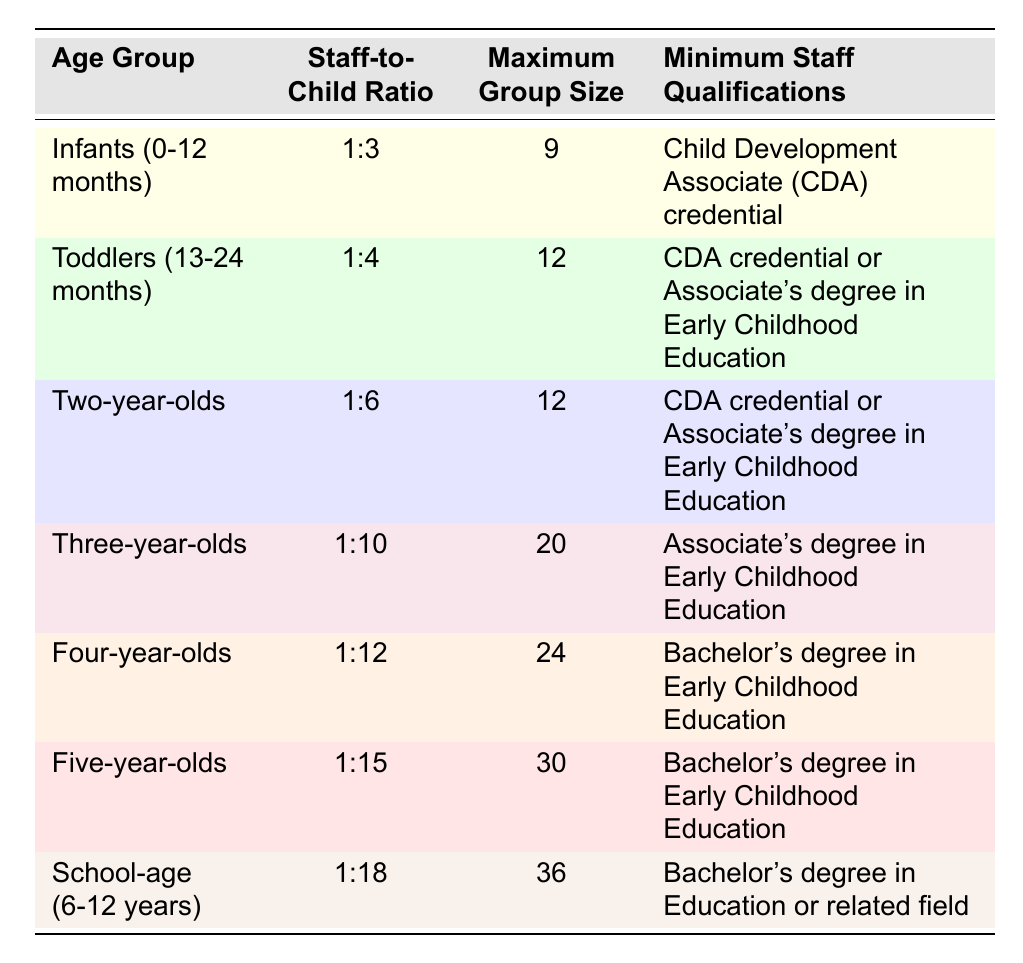What is the staff-to-child ratio for infants? The table states that the staff-to-child ratio for infants (0-12 months) is 1:3.
Answer: 1:3 What maximum group size is allowed for toddlers? According to the table, the maximum group size for toddlers (13-24 months) is 12.
Answer: 12 Do two-year-olds require the same minimum staff qualifications as toddlers? The minimum staff qualifications for both two-year-olds and toddlers are CDA credential or Associate's degree in Early Childhood Education, so the answer is yes.
Answer: Yes What is the maximum group size for four-year-olds and what is the corresponding staff-to-child ratio? The table indicates that the maximum group size for four-year-olds is 24 with a staff-to-child ratio of 1:12.
Answer: 24, 1:12 Which age group has the highest staff-to-child ratio? By examining the ratios in the table, the school-age (6-12 years) group has a ratio of 1:18, which is highest compared to other groups.
Answer: School-age (6-12 years) What is the difference between the maximum group sizes of infants and five-year-olds? The maximum group size for infants is 9 and for five-year-olds is 30. The difference is calculated as 30 - 9 = 21.
Answer: 21 How many age groups require at least a Bachelor's degree in Early Childhood Education? The table reveals that four-year-olds and five-year-olds both require a Bachelor's degree in Early Childhood Education, which totals to two age groups.
Answer: 2 Is the minimum staff qualification for school-age children lower than that for toddlers? The minimum staff qualifications indicate that school-age children require a Bachelor's degree in Education or related field, which is higher than the CDA credential or Associate's degree required for toddlers. Hence, the answer is no.
Answer: No What is the average staff-to-child ratio for toddlers, two-year-olds, and three-year-olds? Analyzing the ratios: Toddlers (1:4), Two-year-olds (1:6), and Three-year-olds (1:10). Converting ratios to numbers: 4, 6, and 10 respectively gives us (4 + 6 + 10) / 3 = 20 / 3 = approx. 6.67.
Answer: 6.67 How many age groups are allowed a maximum group size of 12 or fewer? The age groups with a maximum group size of 12 or fewer are infants (9) and toddlers (12), totaling two age groups.
Answer: 2 What staff qualification is required for three-year-olds and is it different from that of four-year-olds? Three-year-olds require an Associate's degree in Early Childhood Education, while four-year-olds require a Bachelor's degree. Therefore, they are different.
Answer: Yes 